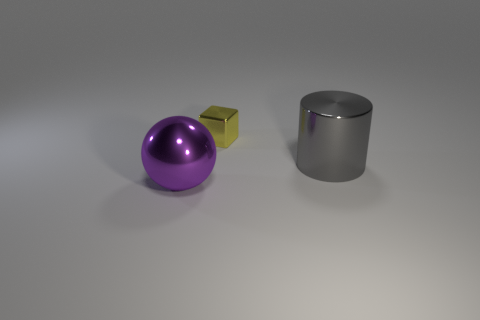Is there anything else of the same color as the large sphere?
Offer a very short reply. No. Does the ball have the same color as the metal object behind the metallic cylinder?
Offer a very short reply. No. How many other things are there of the same size as the metallic block?
Offer a very short reply. 0. What number of spheres are purple metallic things or brown rubber things?
Your response must be concise. 1. Is the shape of the shiny thing behind the big gray object the same as  the large purple object?
Ensure brevity in your answer.  No. Is the number of small objects that are on the left side of the yellow cube greater than the number of big purple spheres?
Offer a very short reply. No. What is the color of the shiny sphere that is the same size as the gray shiny cylinder?
Give a very brief answer. Purple. What number of things are shiny things that are behind the big ball or big red matte objects?
Your answer should be very brief. 2. What material is the object that is in front of the object that is on the right side of the small yellow object?
Offer a very short reply. Metal. Are there any large blue cylinders made of the same material as the gray cylinder?
Offer a very short reply. No. 